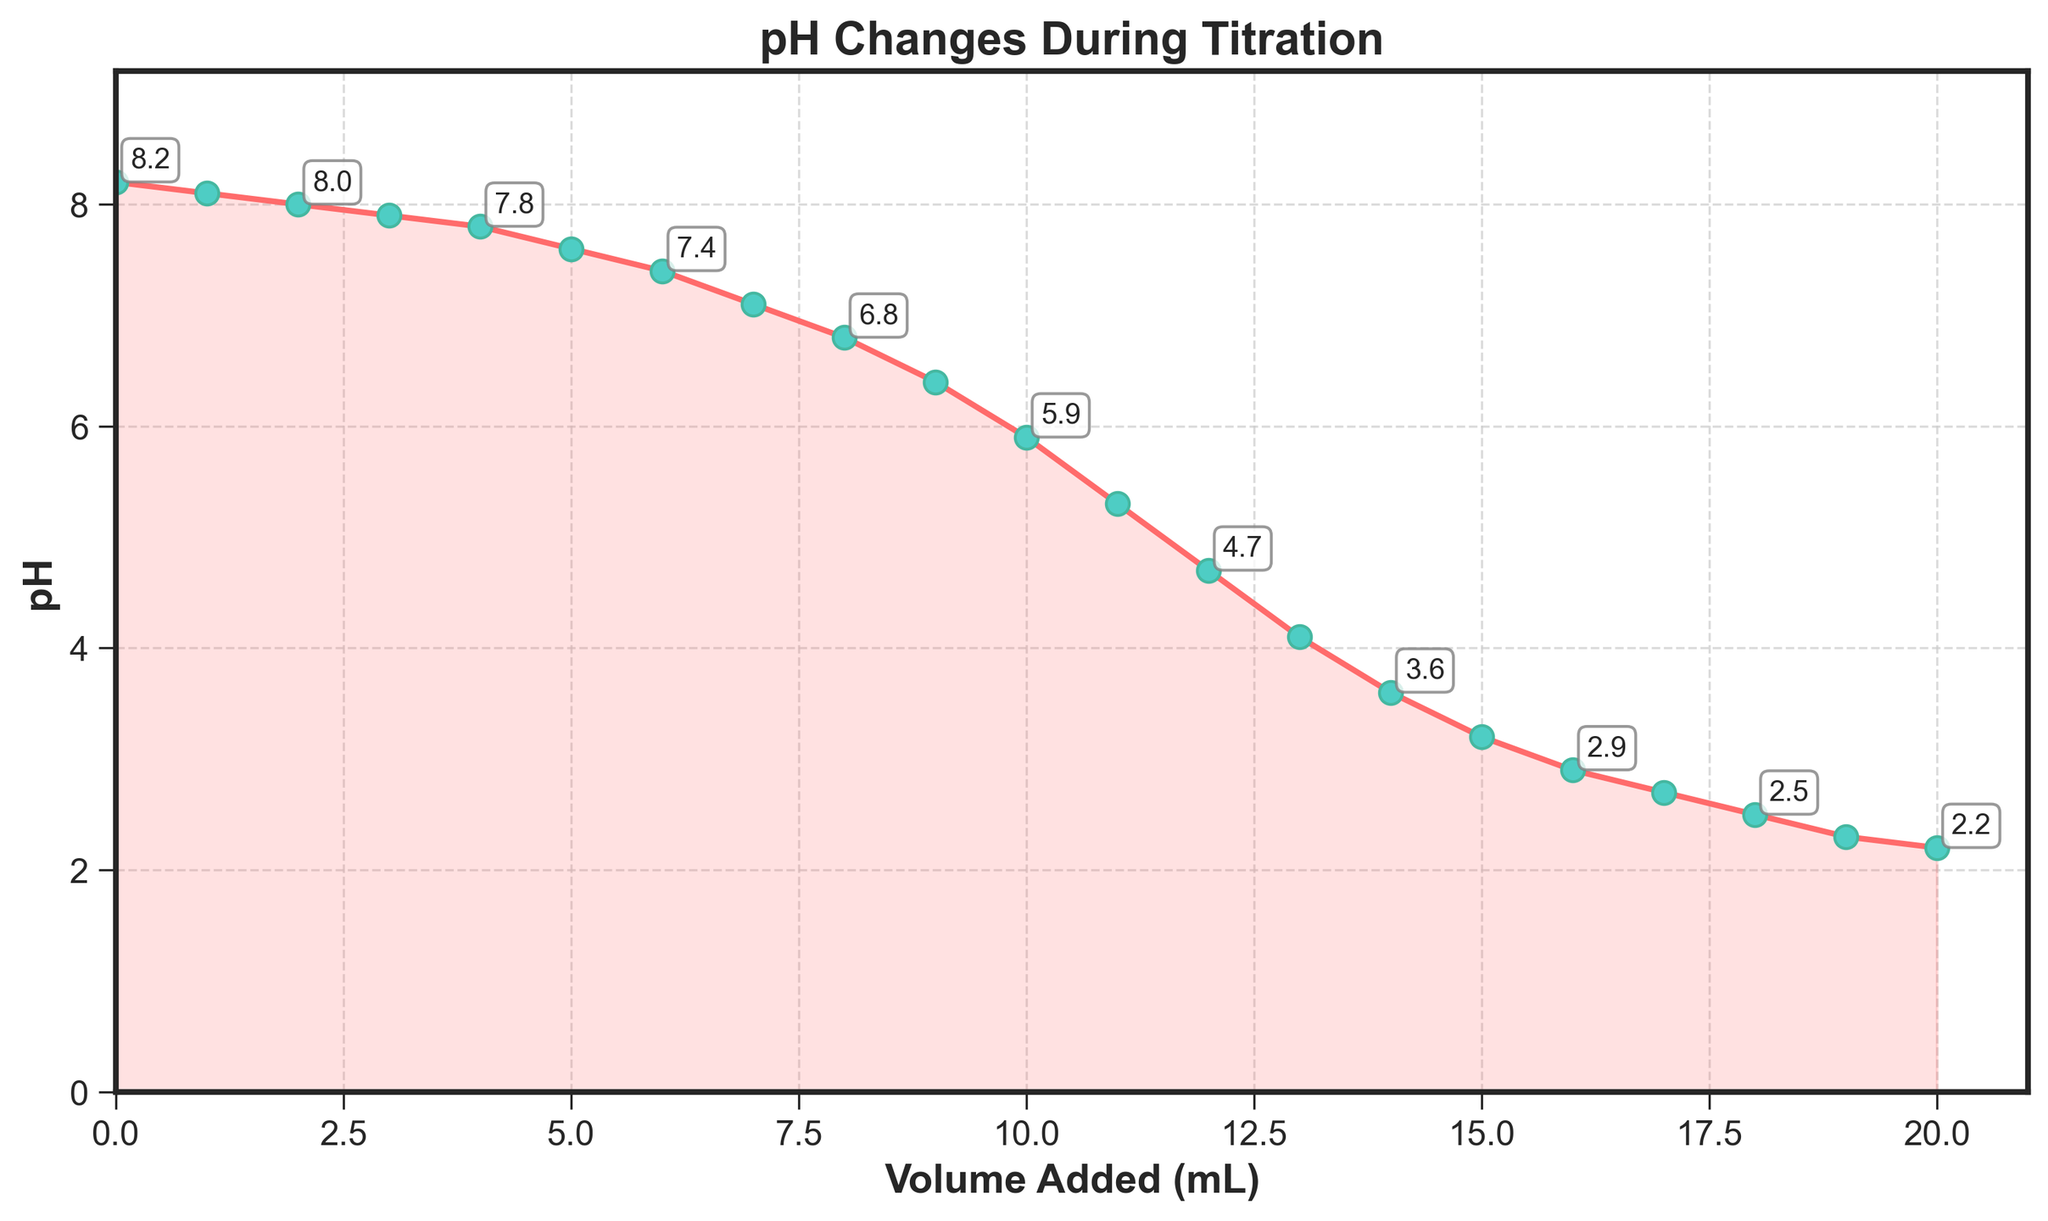What is the initial pH of the solution before titration begins? The initial pH is at the first data point where the volume added is 0 mL. The corresponding pH value is 8.2.
Answer: 8.2 At what added volume does the pH first drop below 5? The pH first drops below 5 at the data point where the volume added is 11 mL, and the corresponding pH value is 4.7.
Answer: 11 mL What is the total decrease in pH from the start to the end of the titration? The initial pH is 8.2 and the final pH is 2.2. The total decrease in pH is 8.2 - 2.2 = 6.0.
Answer: 6.0 By how much does the pH change between 6 mL and 10 mL of titrant added? The pH at 6 mL is 7.4, and at 10 mL, it is 5.9. The pH change is 7.4 - 5.9 = 1.5.
Answer: 1.5 Which volume addition results in the steepest decrease in pH? The steepest decrease in pH occurs between 8 mL and 9 mL of titrant added, as the pH drops from 6.8 to 6.4, a change of 0.4 within 1 mL.
Answer: 8-9 mL What is the average pH after 10 mL of titrant has been added? To find the average pH after 10 mL, consider the pH values from 11 mL to 20 mL (5.3, 4.7, 4.1, 3.6, 3.2, 2.9, 2.7, 2.5, 2.3, 2.2). Sum these values (5.3 + 4.7 + 4.1 + 3.6 + 3.2 + 2.9 + 2.7 + 2.5 + 2.3 + 2.2) = 33.5, then divide by 10 to find the average: 33.5 / 10 = 3.35.
Answer: 3.35 What is the pH when 8 mL of titrant is added, and how does it compare with the pH when 12 mL is added? At 8 mL, the pH is 6.8, and at 12 mL, it is 4.7. Comparing these, 6.8 is greater than 4.7 by 2.1 units.
Answer: 6.8 vs 4.7, difference of 2.1 What is the median pH value of the entire titration process? There are 21 pH values. Sorting them gives: (2.2, 2.3, 2.5, 2.7, 2.9, 3.2, 3.6, 4.1, 4.7, 5.3, 5.9, 6.4, 6.8, 7.1, 7.4, 7.6, 7.8, 7.9, 8.0, 8.1, 8.2). The median, being the middle value, is the 11th value, which is 5.9.
Answer: 5.9 How does the pH change visually across the entire titration process, and are there any significant patterns? Visually, the pH decreases gradually at first, then rapidly drops more sharply around the midpoint, and finally decreases more slowly towards the end. This indicates a stronger buffering region initially, followed by a quicker transition as the titration progresses.
Answer: Gradual, sharp, gradual 